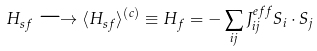Convert formula to latex. <formula><loc_0><loc_0><loc_500><loc_500>H _ { s f } \longrightarrow \langle H _ { s f } \rangle ^ { ( c ) } \equiv H _ { f } = - \sum _ { i j } J _ { i j } ^ { e f f } S _ { i } \cdot S _ { j }</formula> 